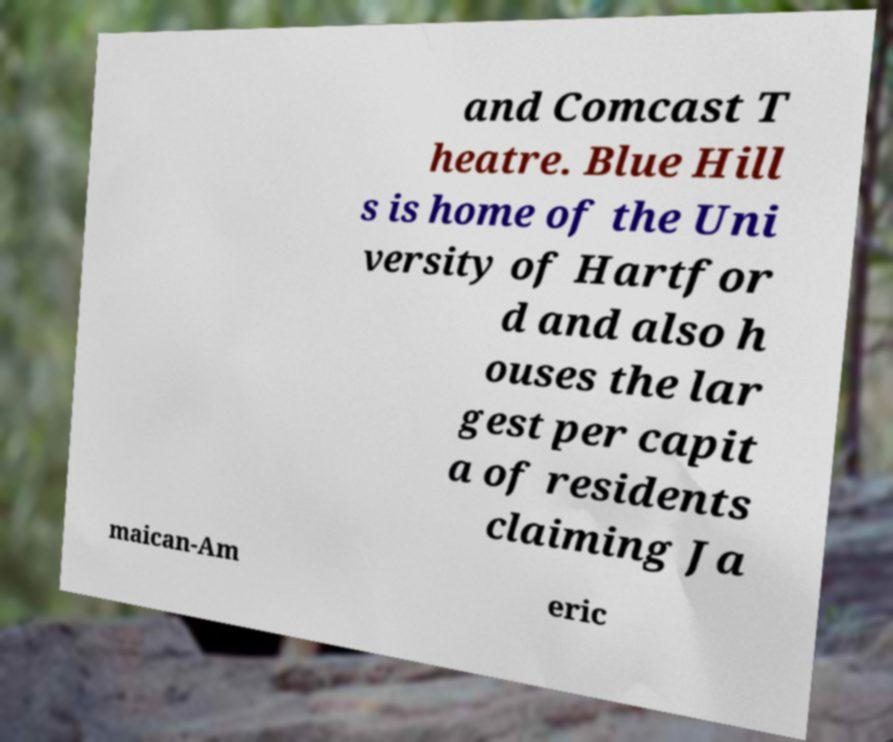What messages or text are displayed in this image? I need them in a readable, typed format. and Comcast T heatre. Blue Hill s is home of the Uni versity of Hartfor d and also h ouses the lar gest per capit a of residents claiming Ja maican-Am eric 